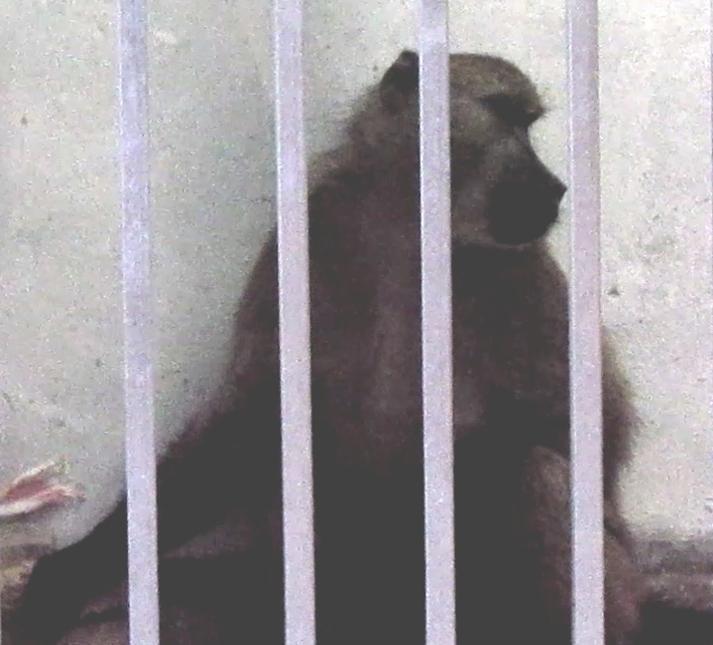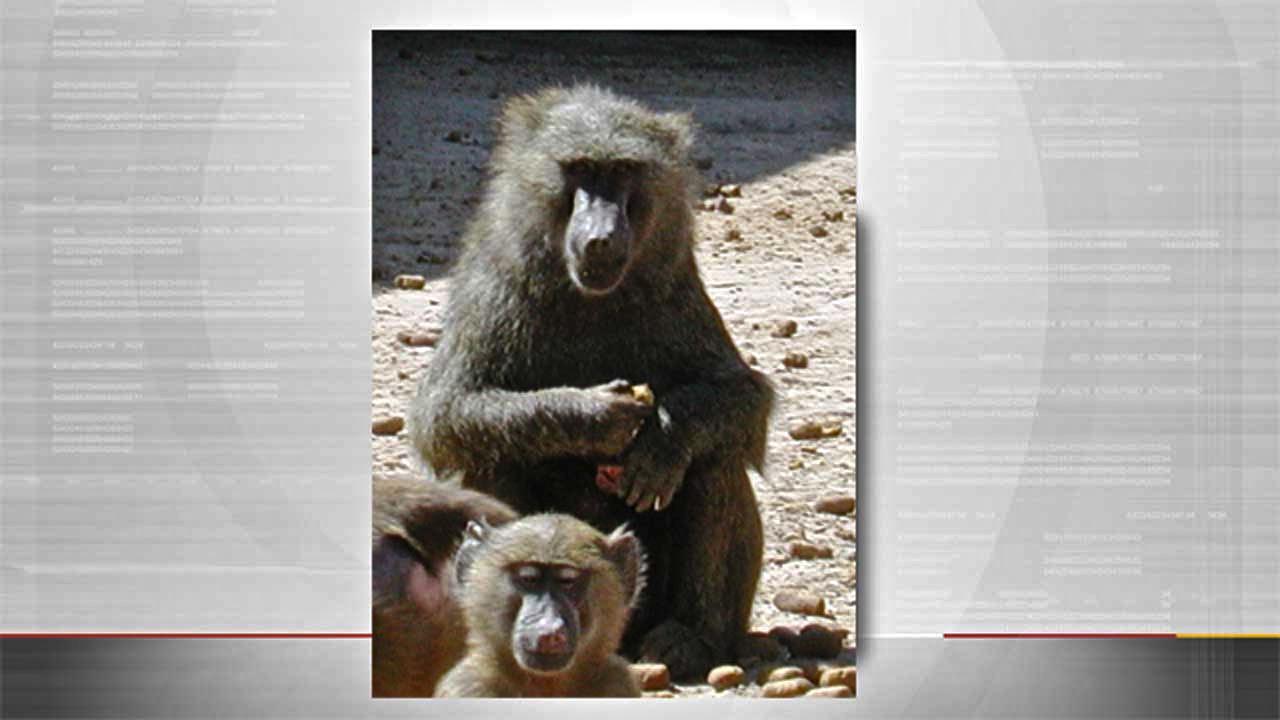The first image is the image on the left, the second image is the image on the right. For the images shown, is this caption "There is one statue that features one brown monkey and another statue that depicts three black monkeys in various poses." true? Answer yes or no. No. 